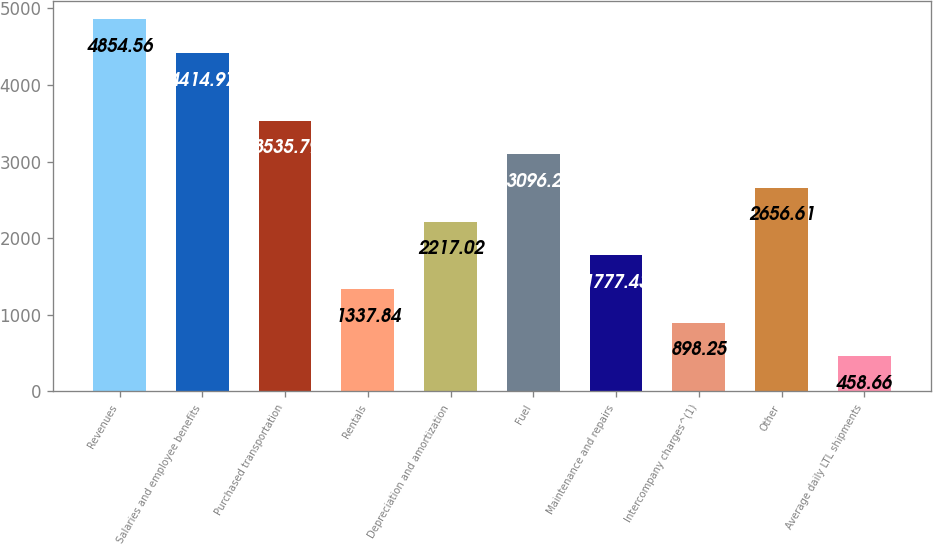<chart> <loc_0><loc_0><loc_500><loc_500><bar_chart><fcel>Revenues<fcel>Salaries and employee benefits<fcel>Purchased transportation<fcel>Rentals<fcel>Depreciation and amortization<fcel>Fuel<fcel>Maintenance and repairs<fcel>Intercompany charges^(1)<fcel>Other<fcel>Average daily LTL shipments<nl><fcel>4854.56<fcel>4414.97<fcel>3535.79<fcel>1337.84<fcel>2217.02<fcel>3096.2<fcel>1777.43<fcel>898.25<fcel>2656.61<fcel>458.66<nl></chart> 